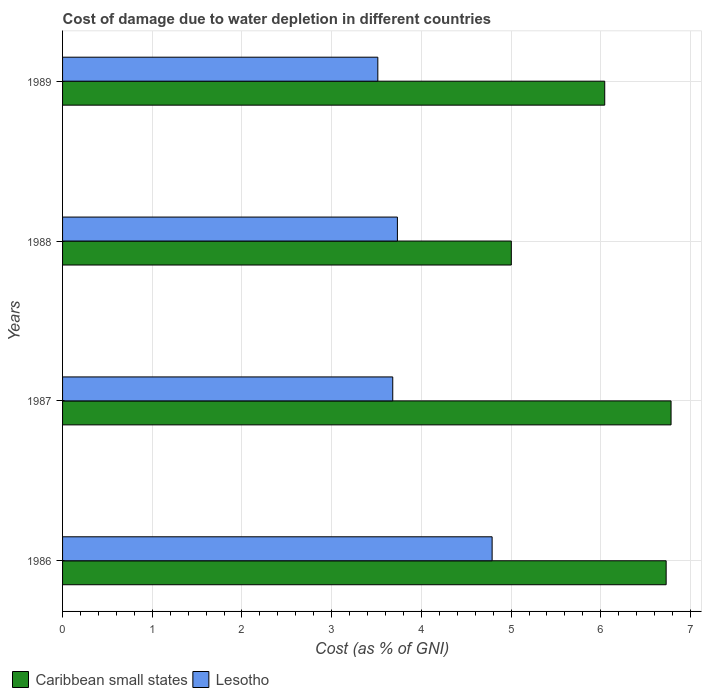How many different coloured bars are there?
Give a very brief answer. 2. Are the number of bars on each tick of the Y-axis equal?
Offer a very short reply. Yes. How many bars are there on the 2nd tick from the bottom?
Keep it short and to the point. 2. What is the cost of damage caused due to water depletion in Lesotho in 1988?
Ensure brevity in your answer.  3.73. Across all years, what is the maximum cost of damage caused due to water depletion in Lesotho?
Keep it short and to the point. 4.79. Across all years, what is the minimum cost of damage caused due to water depletion in Caribbean small states?
Offer a very short reply. 5. What is the total cost of damage caused due to water depletion in Lesotho in the graph?
Your answer should be very brief. 15.72. What is the difference between the cost of damage caused due to water depletion in Lesotho in 1987 and that in 1989?
Ensure brevity in your answer.  0.17. What is the difference between the cost of damage caused due to water depletion in Lesotho in 1987 and the cost of damage caused due to water depletion in Caribbean small states in 1989?
Provide a succinct answer. -2.36. What is the average cost of damage caused due to water depletion in Lesotho per year?
Give a very brief answer. 3.93. In the year 1987, what is the difference between the cost of damage caused due to water depletion in Caribbean small states and cost of damage caused due to water depletion in Lesotho?
Keep it short and to the point. 3.1. In how many years, is the cost of damage caused due to water depletion in Caribbean small states greater than 5.4 %?
Keep it short and to the point. 3. What is the ratio of the cost of damage caused due to water depletion in Lesotho in 1987 to that in 1988?
Give a very brief answer. 0.99. Is the cost of damage caused due to water depletion in Lesotho in 1987 less than that in 1988?
Your answer should be very brief. Yes. Is the difference between the cost of damage caused due to water depletion in Caribbean small states in 1987 and 1988 greater than the difference between the cost of damage caused due to water depletion in Lesotho in 1987 and 1988?
Your answer should be very brief. Yes. What is the difference between the highest and the second highest cost of damage caused due to water depletion in Caribbean small states?
Keep it short and to the point. 0.05. What is the difference between the highest and the lowest cost of damage caused due to water depletion in Lesotho?
Offer a terse response. 1.27. What does the 2nd bar from the top in 1989 represents?
Your response must be concise. Caribbean small states. What does the 2nd bar from the bottom in 1986 represents?
Your response must be concise. Lesotho. Are all the bars in the graph horizontal?
Keep it short and to the point. Yes. How many years are there in the graph?
Ensure brevity in your answer.  4. Are the values on the major ticks of X-axis written in scientific E-notation?
Provide a succinct answer. No. Does the graph contain grids?
Your response must be concise. Yes. What is the title of the graph?
Give a very brief answer. Cost of damage due to water depletion in different countries. What is the label or title of the X-axis?
Provide a short and direct response. Cost (as % of GNI). What is the label or title of the Y-axis?
Your response must be concise. Years. What is the Cost (as % of GNI) in Caribbean small states in 1986?
Ensure brevity in your answer.  6.73. What is the Cost (as % of GNI) in Lesotho in 1986?
Your answer should be very brief. 4.79. What is the Cost (as % of GNI) in Caribbean small states in 1987?
Your answer should be compact. 6.78. What is the Cost (as % of GNI) of Lesotho in 1987?
Offer a terse response. 3.68. What is the Cost (as % of GNI) in Caribbean small states in 1988?
Your answer should be very brief. 5. What is the Cost (as % of GNI) of Lesotho in 1988?
Give a very brief answer. 3.73. What is the Cost (as % of GNI) in Caribbean small states in 1989?
Your answer should be very brief. 6.04. What is the Cost (as % of GNI) of Lesotho in 1989?
Keep it short and to the point. 3.51. Across all years, what is the maximum Cost (as % of GNI) of Caribbean small states?
Make the answer very short. 6.78. Across all years, what is the maximum Cost (as % of GNI) in Lesotho?
Your response must be concise. 4.79. Across all years, what is the minimum Cost (as % of GNI) of Caribbean small states?
Keep it short and to the point. 5. Across all years, what is the minimum Cost (as % of GNI) of Lesotho?
Give a very brief answer. 3.51. What is the total Cost (as % of GNI) in Caribbean small states in the graph?
Offer a terse response. 24.56. What is the total Cost (as % of GNI) in Lesotho in the graph?
Ensure brevity in your answer.  15.72. What is the difference between the Cost (as % of GNI) of Caribbean small states in 1986 and that in 1987?
Give a very brief answer. -0.05. What is the difference between the Cost (as % of GNI) in Lesotho in 1986 and that in 1987?
Your answer should be very brief. 1.11. What is the difference between the Cost (as % of GNI) in Caribbean small states in 1986 and that in 1988?
Your answer should be very brief. 1.73. What is the difference between the Cost (as % of GNI) of Lesotho in 1986 and that in 1988?
Keep it short and to the point. 1.06. What is the difference between the Cost (as % of GNI) in Caribbean small states in 1986 and that in 1989?
Keep it short and to the point. 0.68. What is the difference between the Cost (as % of GNI) in Lesotho in 1986 and that in 1989?
Provide a succinct answer. 1.27. What is the difference between the Cost (as % of GNI) of Caribbean small states in 1987 and that in 1988?
Provide a succinct answer. 1.78. What is the difference between the Cost (as % of GNI) in Lesotho in 1987 and that in 1988?
Keep it short and to the point. -0.05. What is the difference between the Cost (as % of GNI) of Caribbean small states in 1987 and that in 1989?
Provide a succinct answer. 0.74. What is the difference between the Cost (as % of GNI) in Lesotho in 1987 and that in 1989?
Give a very brief answer. 0.17. What is the difference between the Cost (as % of GNI) in Caribbean small states in 1988 and that in 1989?
Provide a short and direct response. -1.04. What is the difference between the Cost (as % of GNI) of Lesotho in 1988 and that in 1989?
Make the answer very short. 0.22. What is the difference between the Cost (as % of GNI) in Caribbean small states in 1986 and the Cost (as % of GNI) in Lesotho in 1987?
Provide a short and direct response. 3.05. What is the difference between the Cost (as % of GNI) of Caribbean small states in 1986 and the Cost (as % of GNI) of Lesotho in 1988?
Give a very brief answer. 3. What is the difference between the Cost (as % of GNI) of Caribbean small states in 1986 and the Cost (as % of GNI) of Lesotho in 1989?
Your response must be concise. 3.21. What is the difference between the Cost (as % of GNI) of Caribbean small states in 1987 and the Cost (as % of GNI) of Lesotho in 1988?
Provide a succinct answer. 3.05. What is the difference between the Cost (as % of GNI) in Caribbean small states in 1987 and the Cost (as % of GNI) in Lesotho in 1989?
Your answer should be very brief. 3.27. What is the difference between the Cost (as % of GNI) of Caribbean small states in 1988 and the Cost (as % of GNI) of Lesotho in 1989?
Give a very brief answer. 1.49. What is the average Cost (as % of GNI) in Caribbean small states per year?
Ensure brevity in your answer.  6.14. What is the average Cost (as % of GNI) in Lesotho per year?
Provide a succinct answer. 3.93. In the year 1986, what is the difference between the Cost (as % of GNI) of Caribbean small states and Cost (as % of GNI) of Lesotho?
Give a very brief answer. 1.94. In the year 1987, what is the difference between the Cost (as % of GNI) in Caribbean small states and Cost (as % of GNI) in Lesotho?
Offer a very short reply. 3.1. In the year 1988, what is the difference between the Cost (as % of GNI) of Caribbean small states and Cost (as % of GNI) of Lesotho?
Offer a very short reply. 1.27. In the year 1989, what is the difference between the Cost (as % of GNI) in Caribbean small states and Cost (as % of GNI) in Lesotho?
Provide a short and direct response. 2.53. What is the ratio of the Cost (as % of GNI) in Caribbean small states in 1986 to that in 1987?
Provide a short and direct response. 0.99. What is the ratio of the Cost (as % of GNI) in Lesotho in 1986 to that in 1987?
Ensure brevity in your answer.  1.3. What is the ratio of the Cost (as % of GNI) of Caribbean small states in 1986 to that in 1988?
Offer a terse response. 1.35. What is the ratio of the Cost (as % of GNI) of Lesotho in 1986 to that in 1988?
Offer a very short reply. 1.28. What is the ratio of the Cost (as % of GNI) of Caribbean small states in 1986 to that in 1989?
Provide a succinct answer. 1.11. What is the ratio of the Cost (as % of GNI) of Lesotho in 1986 to that in 1989?
Ensure brevity in your answer.  1.36. What is the ratio of the Cost (as % of GNI) in Caribbean small states in 1987 to that in 1988?
Ensure brevity in your answer.  1.36. What is the ratio of the Cost (as % of GNI) of Lesotho in 1987 to that in 1988?
Provide a short and direct response. 0.99. What is the ratio of the Cost (as % of GNI) of Caribbean small states in 1987 to that in 1989?
Keep it short and to the point. 1.12. What is the ratio of the Cost (as % of GNI) in Lesotho in 1987 to that in 1989?
Provide a short and direct response. 1.05. What is the ratio of the Cost (as % of GNI) of Caribbean small states in 1988 to that in 1989?
Your answer should be compact. 0.83. What is the ratio of the Cost (as % of GNI) of Lesotho in 1988 to that in 1989?
Give a very brief answer. 1.06. What is the difference between the highest and the second highest Cost (as % of GNI) of Caribbean small states?
Offer a terse response. 0.05. What is the difference between the highest and the second highest Cost (as % of GNI) of Lesotho?
Make the answer very short. 1.06. What is the difference between the highest and the lowest Cost (as % of GNI) in Caribbean small states?
Your answer should be very brief. 1.78. What is the difference between the highest and the lowest Cost (as % of GNI) of Lesotho?
Offer a very short reply. 1.27. 